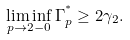Convert formula to latex. <formula><loc_0><loc_0><loc_500><loc_500>\liminf _ { p \to 2 - 0 } \Gamma _ { p } ^ { ^ { * } } \geq 2 \gamma _ { 2 } .</formula> 